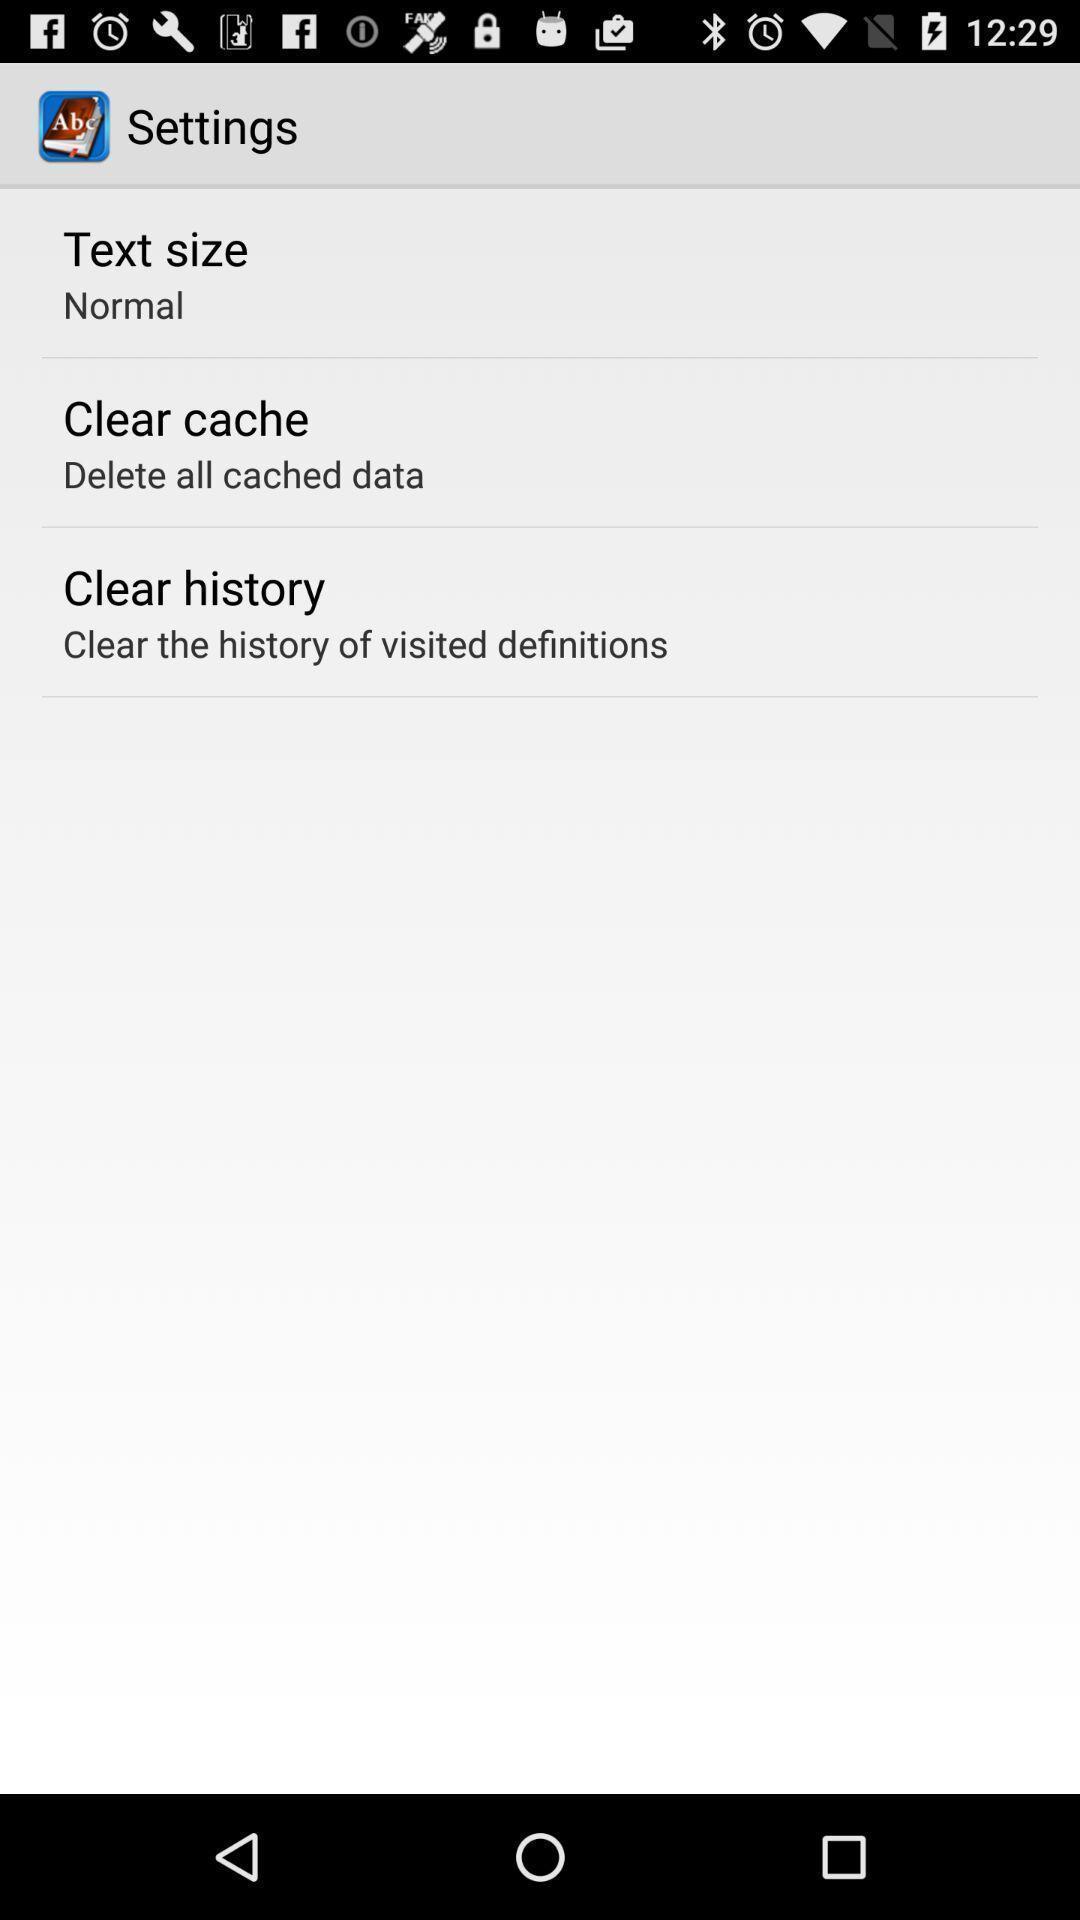Tell me what you see in this picture. Settings page in translator application. 